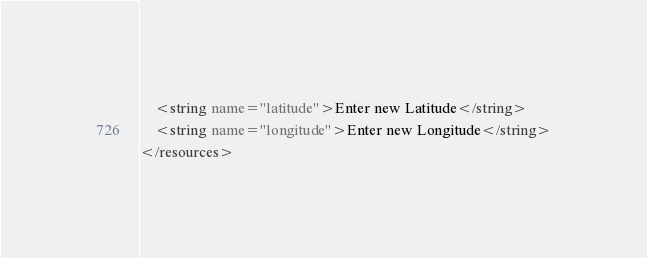<code> <loc_0><loc_0><loc_500><loc_500><_XML_>    <string name="latitude">Enter new Latitude</string>
    <string name="longitude">Enter new Longitude</string>
</resources></code> 